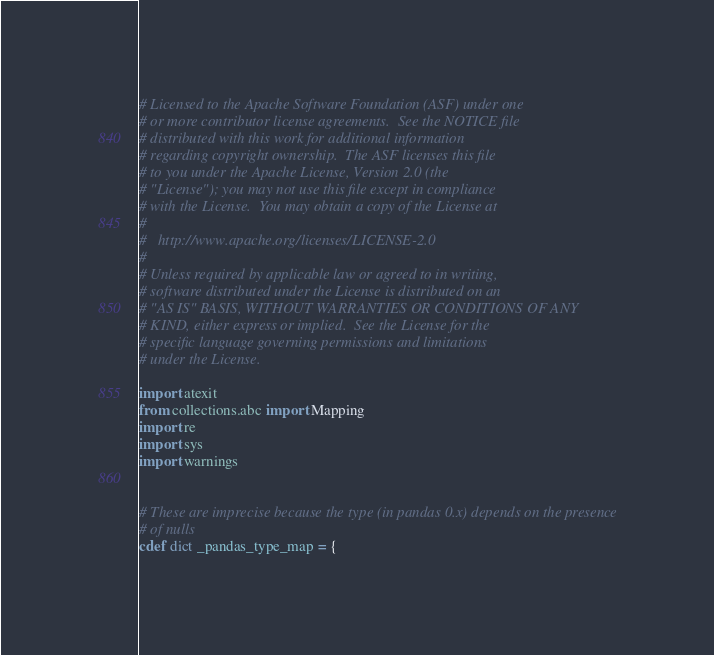<code> <loc_0><loc_0><loc_500><loc_500><_Cython_># Licensed to the Apache Software Foundation (ASF) under one
# or more contributor license agreements.  See the NOTICE file
# distributed with this work for additional information
# regarding copyright ownership.  The ASF licenses this file
# to you under the Apache License, Version 2.0 (the
# "License"); you may not use this file except in compliance
# with the License.  You may obtain a copy of the License at
#
#   http://www.apache.org/licenses/LICENSE-2.0
#
# Unless required by applicable law or agreed to in writing,
# software distributed under the License is distributed on an
# "AS IS" BASIS, WITHOUT WARRANTIES OR CONDITIONS OF ANY
# KIND, either express or implied.  See the License for the
# specific language governing permissions and limitations
# under the License.

import atexit
from collections.abc import Mapping
import re
import sys
import warnings


# These are imprecise because the type (in pandas 0.x) depends on the presence
# of nulls
cdef dict _pandas_type_map = {</code> 